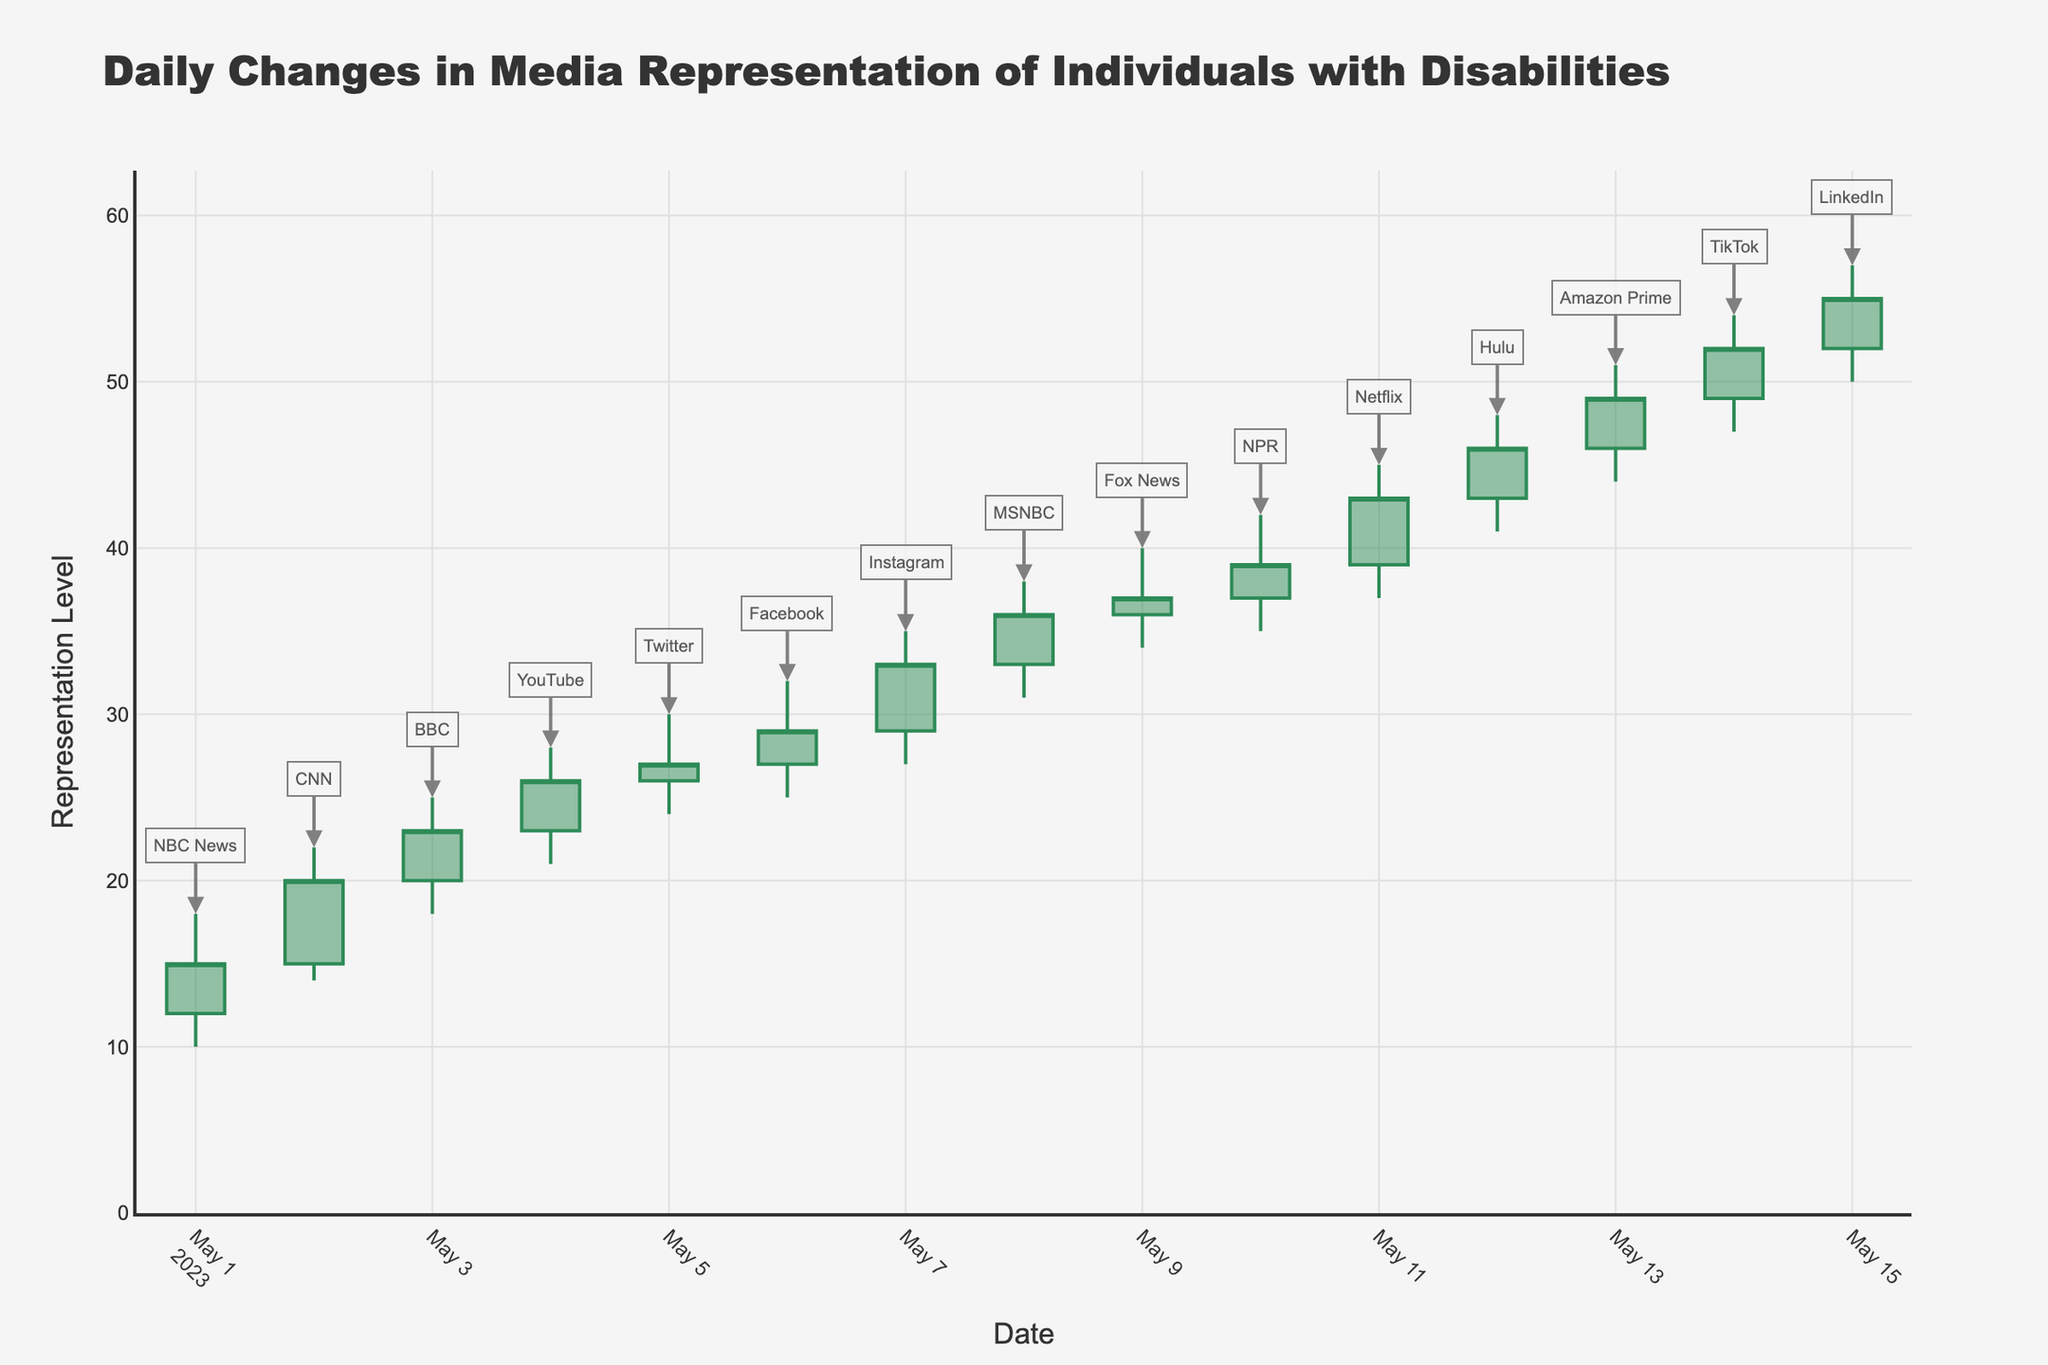What's the title of the chart? The title of the chart is prominently displayed at the top of the figure, which states the main subject or theme of the chart.
Answer: Daily Changes in Media Representation of Individuals with Disabilities How many platforms are represented in this chart? By counting the number of unique dates or data points along the x-axis and matching them with the annotations, we can identify the number of platforms represented.
Answer: 15 Which platform had the highest representation level, and what was it? By examining the chart for the highest point on the y-axis and looking at the annotation at that point, we can determine that the highest level was on May 15 by LinkedIn at a value of 57.
Answer: LinkedIn, 57 Between which dates did the representation level show the greatest increase? By comparing the closing values each day, we can see that the greatest increase is observed from May 13 (Amazon Prime, close at 49) to May 14 (TikTok, close at 52).
Answer: May 13 to May 14 What is the overall trend in the representation level from May 1 to May 15? Observing the chart from the starting date to the ending date, there is a general upward trend in media representation levels.
Answer: Upward trend On which date did the representation level show the largest single-day drop in the closing value? To find the largest single-day drop, compare the closing values for consecutive dates and identify the date with the largest negative difference. No such negative difference is immediately visible; thus, there was no drop.
Answer: None Which platform had a closing value equal to its opening value? By examining the chart and looking for bars where the open and close values are the same, BBC on May 3 shows such a pattern, with opening and closing at 23.
Answer: BBC What was the average closing value over the 15 days? Summing all the closing values and then dividing by the number of days (15), we calculate: (15+20+23+26+27+29+33+36+37+39+43+46+49+52+55)/15 = 494/15 = 32.93.
Answer: 32.93 What's the highest low value observed, and which platform had it? From the chart, by examining the low values, we can see that LinkedIn on May 15 had the highest low value of 50.
Answer: LinkedIn, 50 How did the representation level change for NPR from its opening to closing value on May 10? NPR opened at 37 and closed at 39, indicating an increase. The difference between the open and close is 39 - 37 = 2.
Answer: Increase by 2 